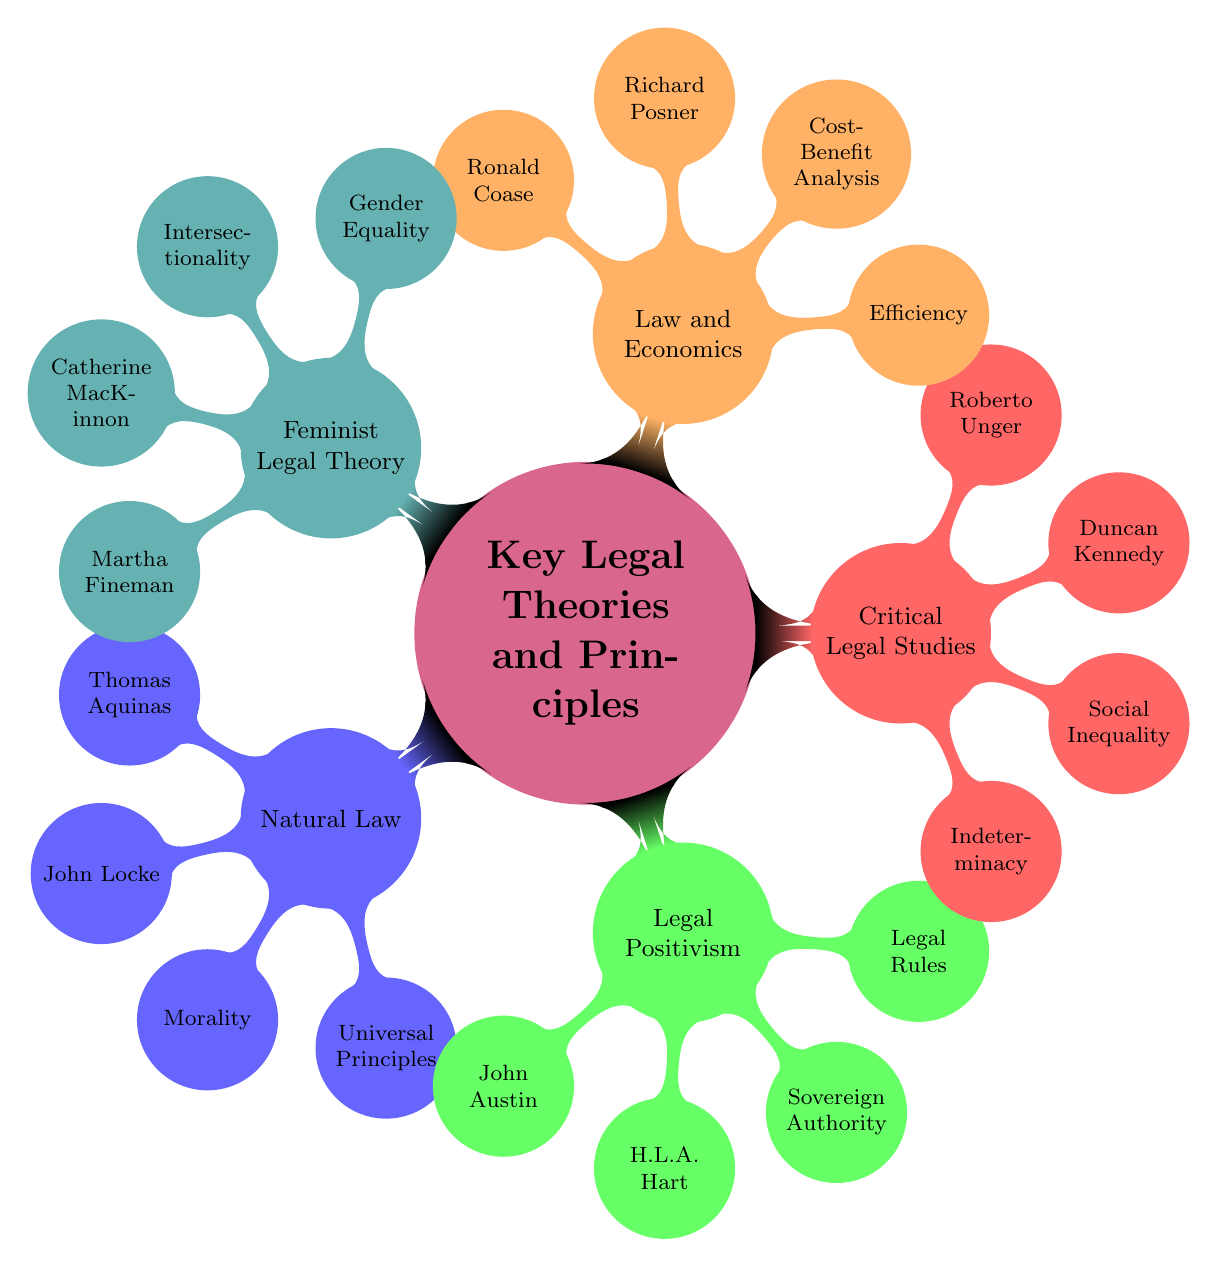What are the core concepts of Legal Positivism? The core concepts of Legal Positivism include "Sovereign Authority" and "Legal Rules", which are stated in the diagram as the key ideas associated with that legal theory.
Answer: Sovereign Authority, Legal Rules Who are the key thinkers in Natural Law? The diagram presents "Natural Law" with associated key thinkers listed as "Thomas Aquinas" and "John Locke". By referring to this section, we identify the two key figures mentioned.
Answer: Thomas Aquinas, John Locke What are the key aspects of Critical Legal Studies? According to the diagram, the key aspects of Critical Legal Studies are "Indeterminacy" and "Social Inequality". These two points can be directly observed in the respective section of the mind map.
Answer: Indeterminacy, Social Inequality Which theory emphasizes Efficiency as a key principle? The diagram clearly indicates that "Law and Economics" pivots around the principle of "Efficiency", showcasing this as a foundational concept within that category of legal thought.
Answer: Law and Economics How many influential scholars are mentioned in Feminist Legal Theory? From the diagram, "Feminist Legal Theory" includes two influential scholars: "Catherine MacKinnon" and "Martha Fineman". Counting these names gives us the total number of scholars associated.
Answer: 2 What relationship exists between Richard Posner and Law and Economics? The mind map connects Richard Posner directly under the "Law and Economics" category, indicating that he is a key figure associated with this legal theory, illustrating his significance in that domain.
Answer: Key Figure Which legal theory includes intersectionality as a core theme? The diagram denotes "Intersectionality" as a core theme specifically under the section dedicated to "Feminist Legal Theory", establishing a clear link to this concept.
Answer: Feminist Legal Theory What is a common theme among the theories presented in the diagram? Upon reviewing the legal theories presented, a common theme might be the pursuit of justice or social norms, but the primary commonality noted throughout is the exploration of relationships between rules and society reflected in all branches.
Answer: Law and Society 